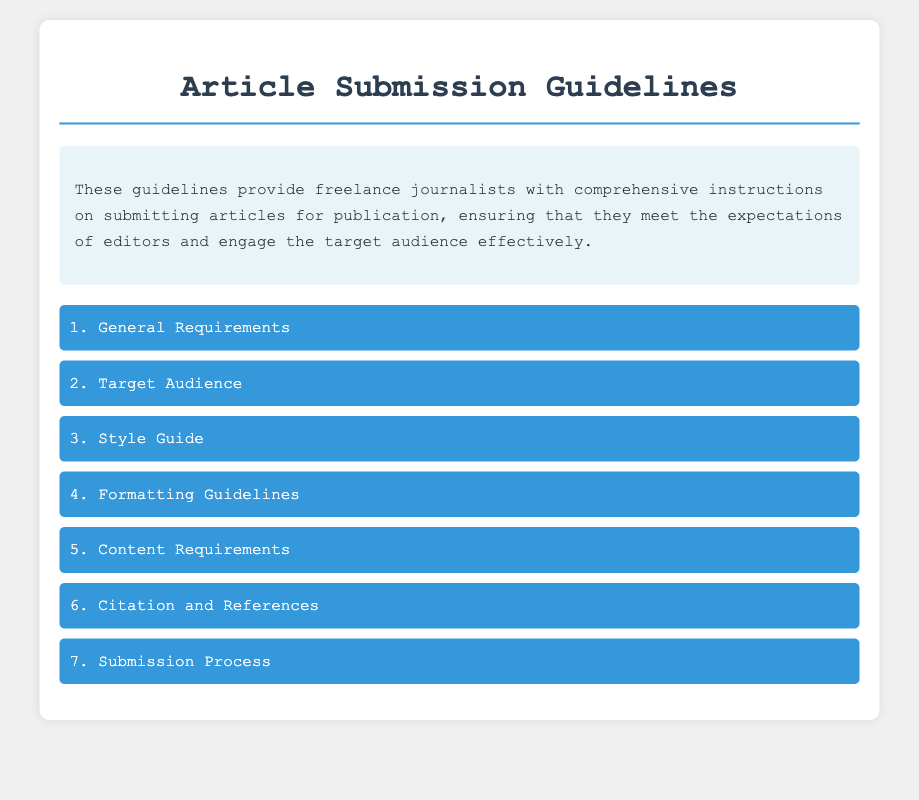What is the maximum word count for articles? The document states that the article must not exceed a specific limit unless otherwise specified, which is 2000 words.
Answer: 2000 words What writing style should be used? The guidelines recommend the use of active voice and a conversational tone.
Answer: Active voice and conversational tone Which citation styles are approved for references? The document mentions two citation styles that should be followed, which are MLA and APA.
Answer: MLA or APA What should be included in the subject line when submitting an article? The subject line should include the phrase 'Article Submission:' followed by the title of the article.
Answer: Article Submission: [Your Title] How long should the author's bio be? The guidelines specify that the author's bio should be brief and have a limit on word count, which is 50 words.
Answer: 50 words What color is used for the menu item headers? The style specifies a particular color for the headers of the menu items in the document.
Answer: White What font and size are required for formatting the article? The document provides specifications on the font style and size for submissions.
Answer: Times New Roman, 12pt What is a key element in the introduction of the article? The introduction should have a specific characteristic, which is to capture interest and outline key points.
Answer: Capture interest and outline key points How should sources be credited in the article? The guidelines indicate how sources must be attributed within the article.
Answer: Proper attribution for all sources used 